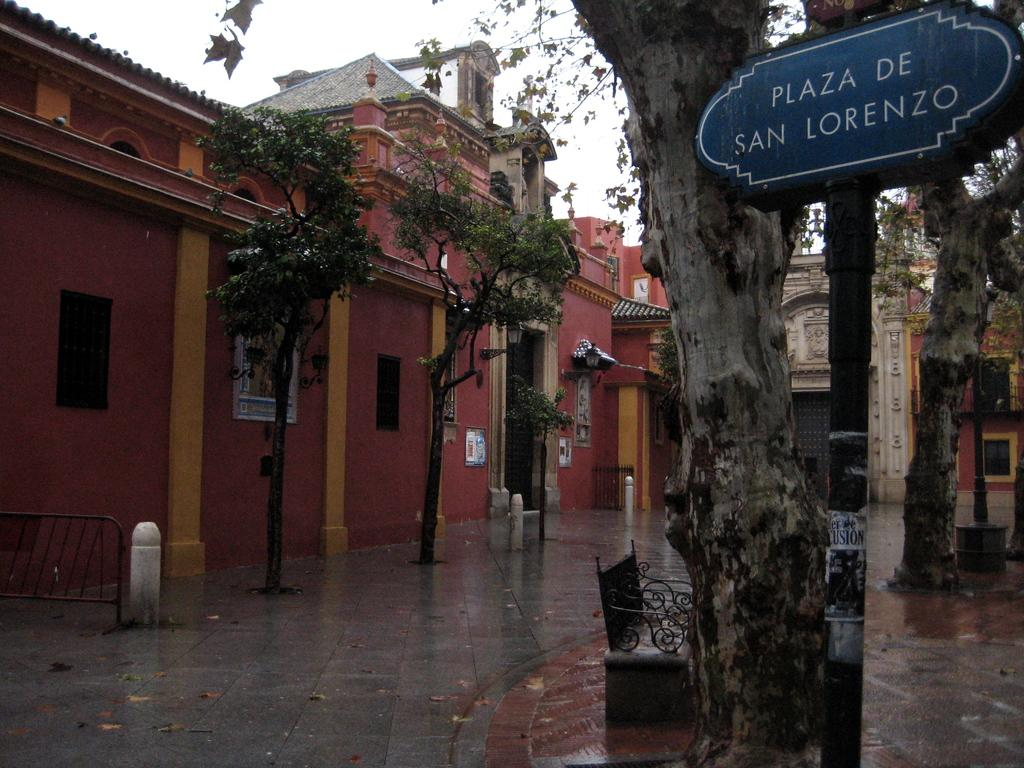<image>
Render a clear and concise summary of the photo. The Plaza De San Lorenzo sign is to the right of the tree. 